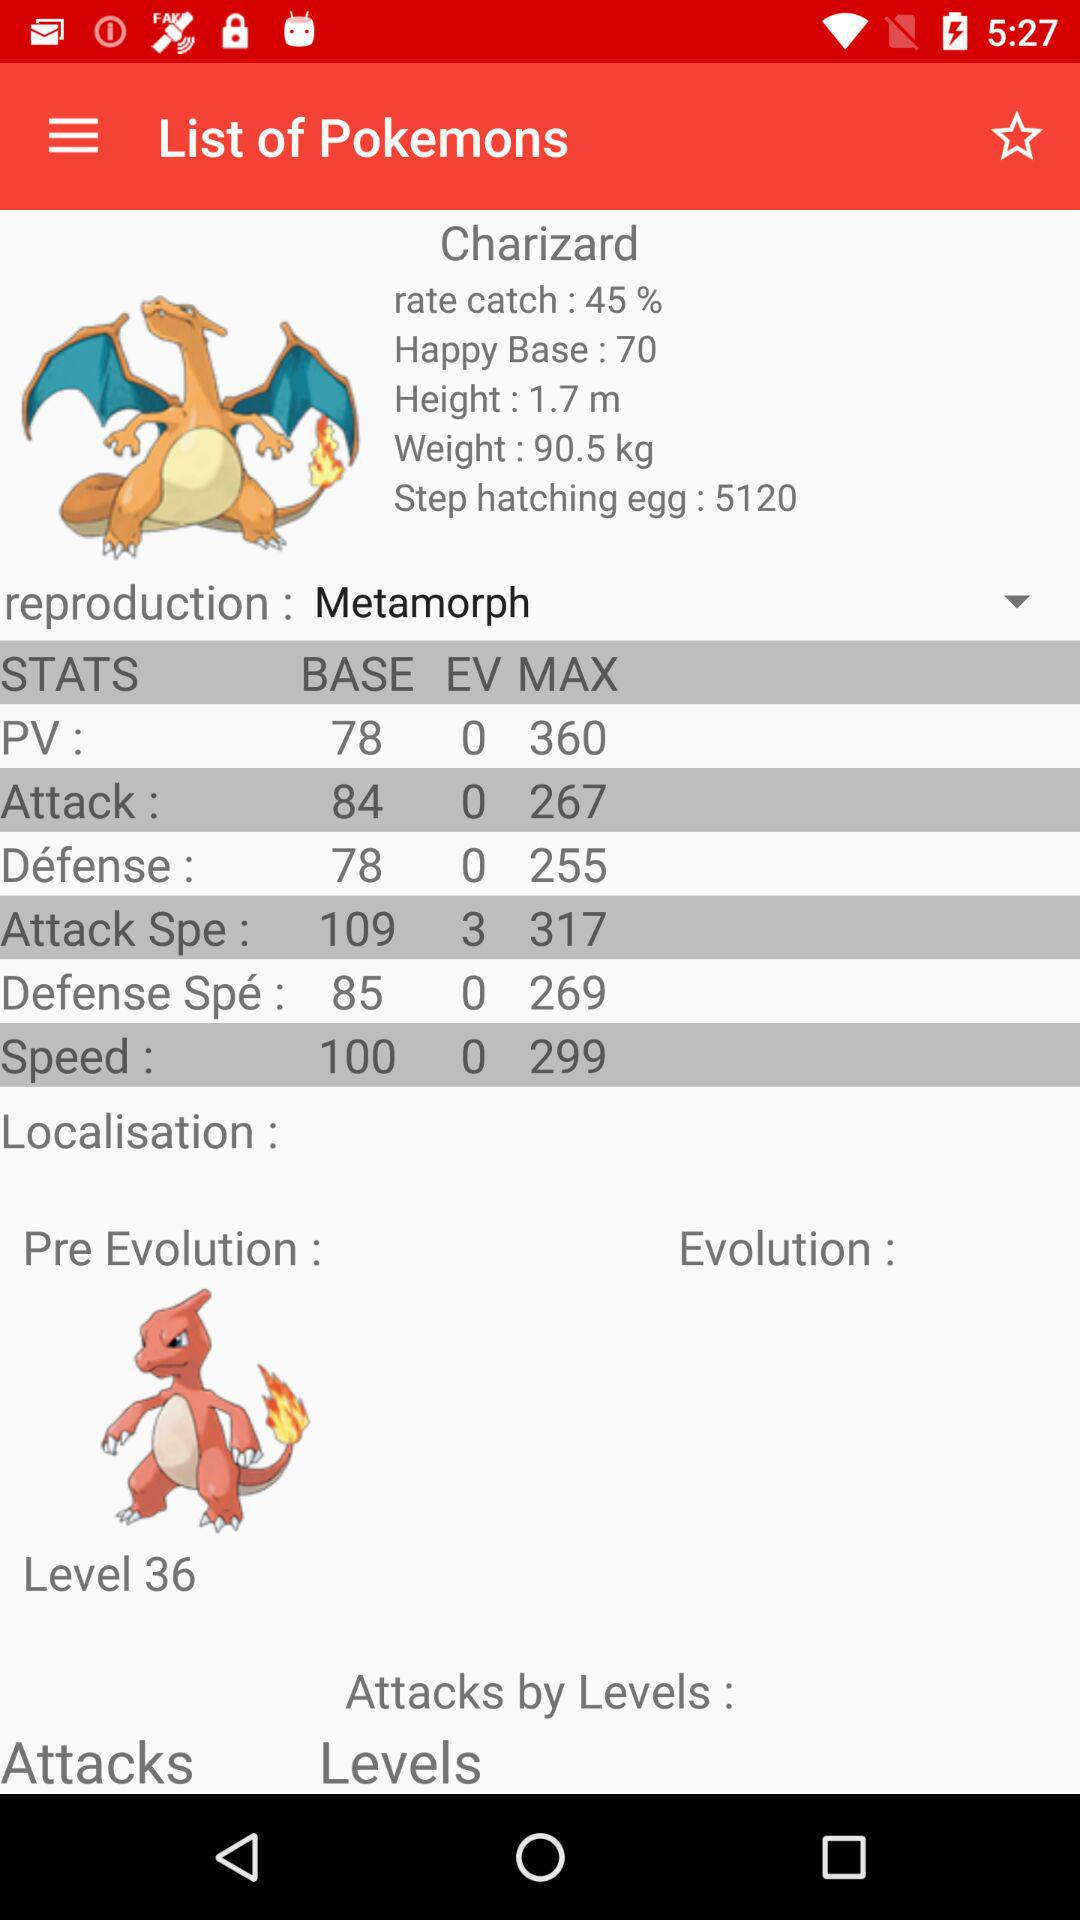What is the selected type of reproduction? The selected type of reproduction is "Metamorph". 